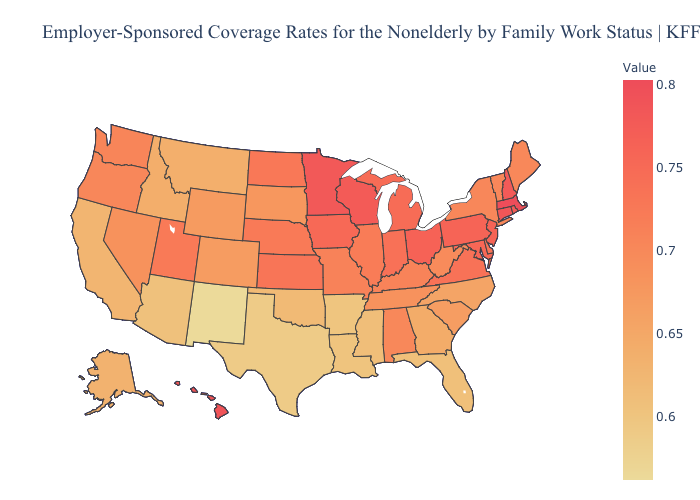Among the states that border Tennessee , which have the highest value?
Quick response, please. Virginia. Does Connecticut have the highest value in the USA?
Be succinct. No. Which states have the highest value in the USA?
Give a very brief answer. Massachusetts. Does the map have missing data?
Concise answer only. No. 